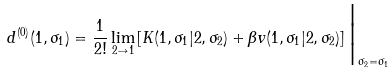<formula> <loc_0><loc_0><loc_500><loc_500>d ^ { ( 0 ) } ( 1 , \sigma _ { 1 } ) = \frac { 1 } { 2 ! } \lim _ { 2 \to 1 } \left [ K ( 1 , \sigma _ { 1 } | 2 , \sigma _ { 2 } ) + \beta v ( 1 , \sigma _ { 1 } | 2 , \sigma _ { 2 } ) \right ] \Big | _ { \sigma _ { 2 } = \sigma _ { 1 } }</formula> 